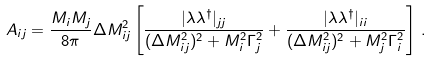Convert formula to latex. <formula><loc_0><loc_0><loc_500><loc_500>A _ { i j } = \frac { M _ { i } M _ { j } } { 8 \pi } \Delta M ^ { 2 } _ { i j } \left [ \frac { | \lambda \lambda ^ { \dagger } | _ { j j } } { ( \Delta M ^ { 2 } _ { i j } ) ^ { 2 } + M _ { i } ^ { 2 } \Gamma _ { j } ^ { 2 } } + \frac { | \lambda \lambda ^ { \dagger } | _ { i i } } { ( \Delta M ^ { 2 } _ { i j } ) ^ { 2 } + M _ { j } ^ { 2 } \Gamma _ { i } ^ { 2 } } \right ] \, .</formula> 